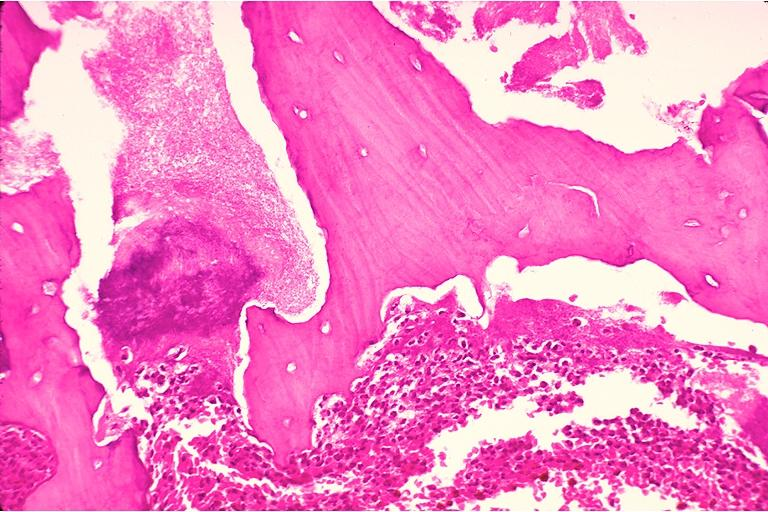s oral present?
Answer the question using a single word or phrase. Yes 